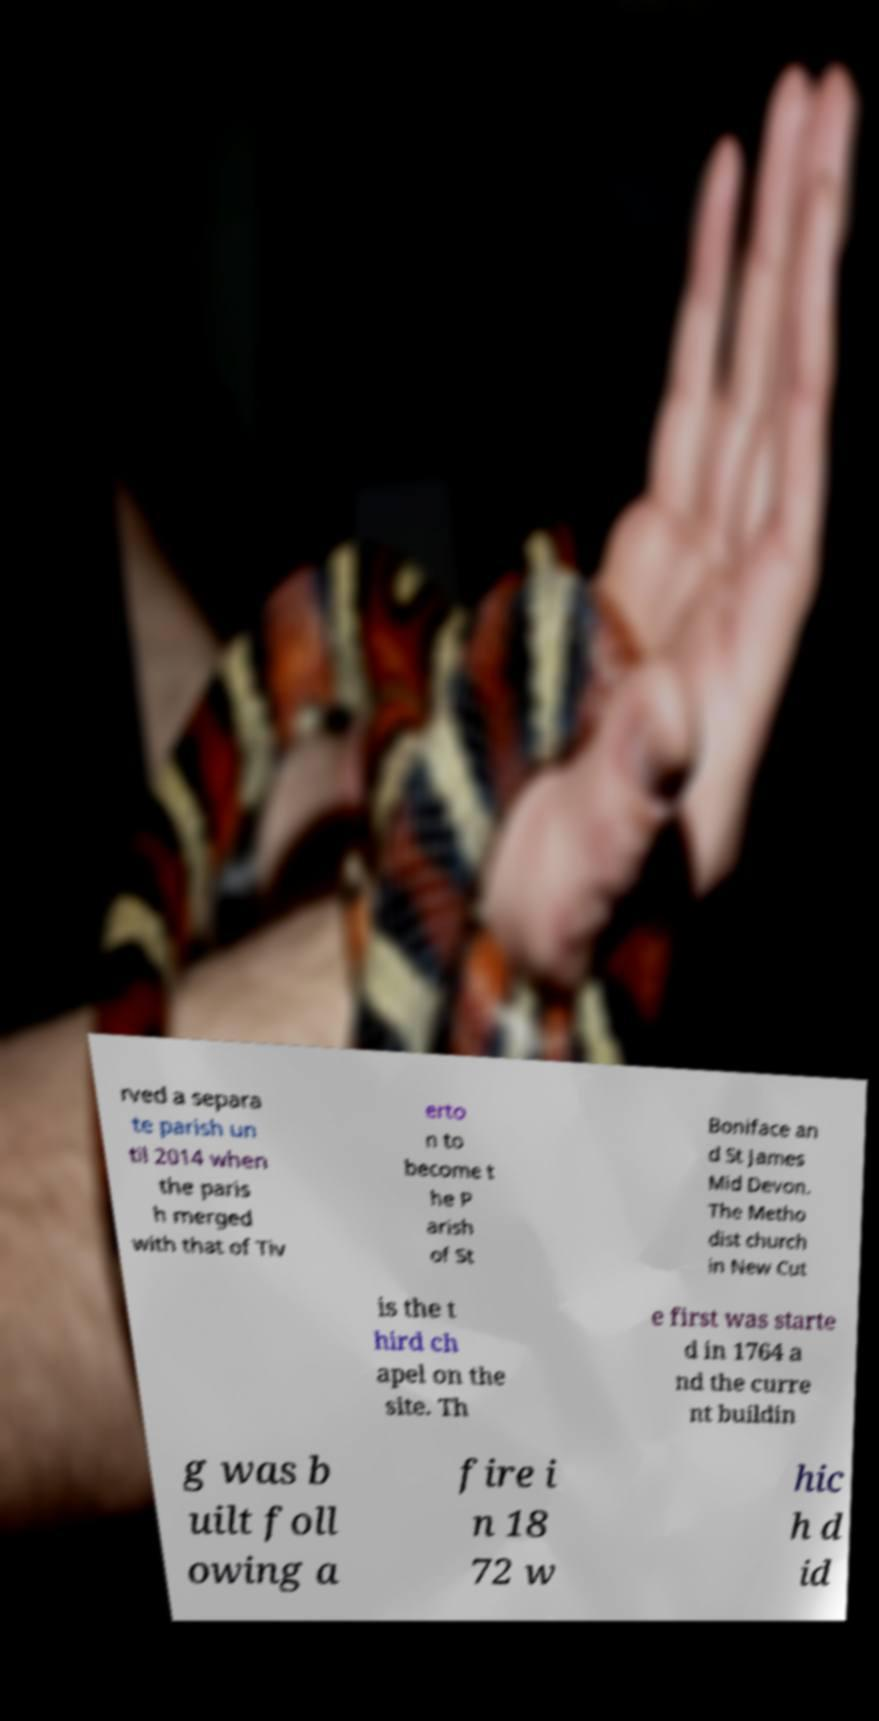For documentation purposes, I need the text within this image transcribed. Could you provide that? rved a separa te parish un til 2014 when the paris h merged with that of Tiv erto n to become t he P arish of St Boniface an d St James Mid Devon. The Metho dist church in New Cut is the t hird ch apel on the site. Th e first was starte d in 1764 a nd the curre nt buildin g was b uilt foll owing a fire i n 18 72 w hic h d id 